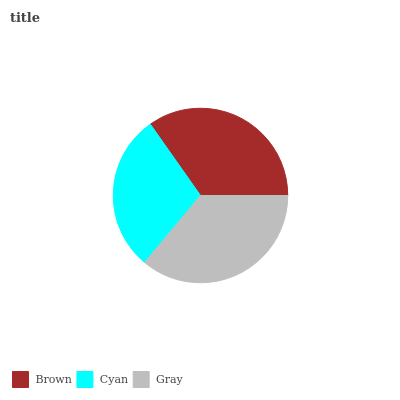Is Cyan the minimum?
Answer yes or no. Yes. Is Gray the maximum?
Answer yes or no. Yes. Is Gray the minimum?
Answer yes or no. No. Is Cyan the maximum?
Answer yes or no. No. Is Gray greater than Cyan?
Answer yes or no. Yes. Is Cyan less than Gray?
Answer yes or no. Yes. Is Cyan greater than Gray?
Answer yes or no. No. Is Gray less than Cyan?
Answer yes or no. No. Is Brown the high median?
Answer yes or no. Yes. Is Brown the low median?
Answer yes or no. Yes. Is Cyan the high median?
Answer yes or no. No. Is Gray the low median?
Answer yes or no. No. 